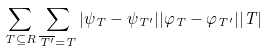Convert formula to latex. <formula><loc_0><loc_0><loc_500><loc_500>\sum _ { T \subseteq R } \sum _ { \overline { T ^ { \prime } } = T } | \psi _ { T } - \psi _ { T ^ { \prime } } | | \varphi _ { T } - \varphi _ { T ^ { \prime } } | | T |</formula> 